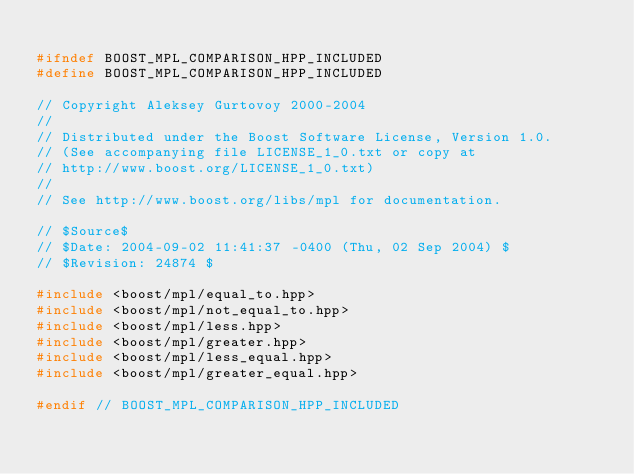<code> <loc_0><loc_0><loc_500><loc_500><_C++_>
#ifndef BOOST_MPL_COMPARISON_HPP_INCLUDED
#define BOOST_MPL_COMPARISON_HPP_INCLUDED

// Copyright Aleksey Gurtovoy 2000-2004
//
// Distributed under the Boost Software License, Version 1.0. 
// (See accompanying file LICENSE_1_0.txt or copy at 
// http://www.boost.org/LICENSE_1_0.txt)
//
// See http://www.boost.org/libs/mpl for documentation.

// $Source$
// $Date: 2004-09-02 11:41:37 -0400 (Thu, 02 Sep 2004) $
// $Revision: 24874 $

#include <boost/mpl/equal_to.hpp>
#include <boost/mpl/not_equal_to.hpp>
#include <boost/mpl/less.hpp>
#include <boost/mpl/greater.hpp>
#include <boost/mpl/less_equal.hpp>
#include <boost/mpl/greater_equal.hpp>

#endif // BOOST_MPL_COMPARISON_HPP_INCLUDED
</code> 